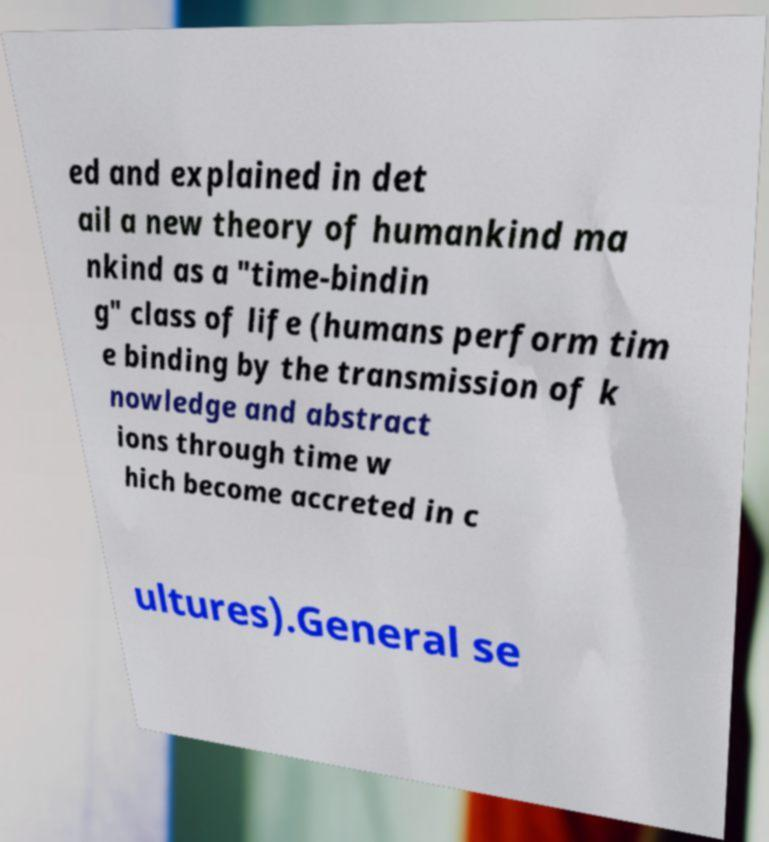Please identify and transcribe the text found in this image. ed and explained in det ail a new theory of humankind ma nkind as a "time-bindin g" class of life (humans perform tim e binding by the transmission of k nowledge and abstract ions through time w hich become accreted in c ultures).General se 